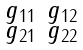<formula> <loc_0><loc_0><loc_500><loc_500>\begin{smallmatrix} g _ { 1 1 } & g _ { 1 2 } \\ g _ { 2 1 } & g _ { 2 2 } \end{smallmatrix}</formula> 